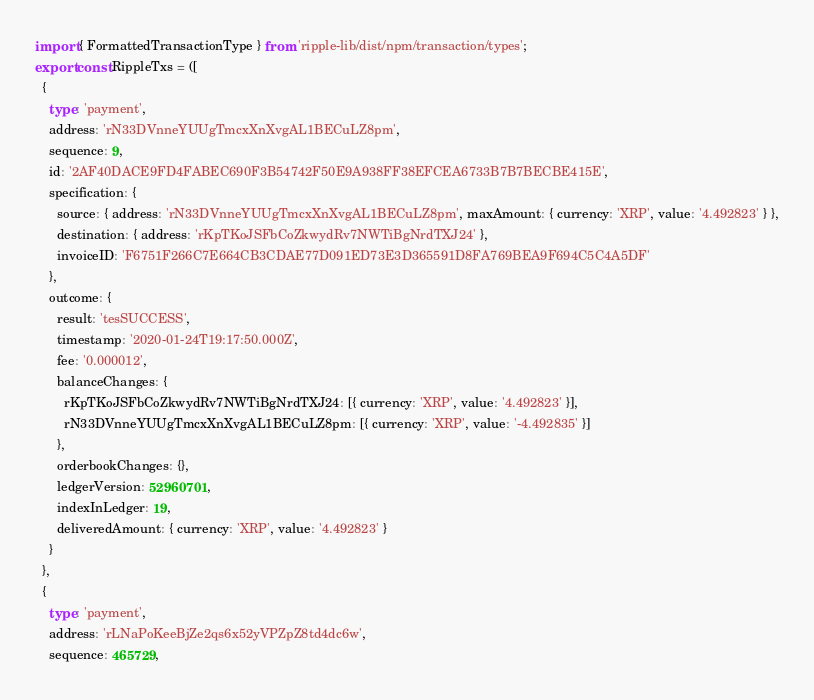Convert code to text. <code><loc_0><loc_0><loc_500><loc_500><_TypeScript_>import { FormattedTransactionType } from 'ripple-lib/dist/npm/transaction/types';
export const RippleTxs = ([
  {
    type: 'payment',
    address: 'rN33DVnneYUUgTmcxXnXvgAL1BECuLZ8pm',
    sequence: 9,
    id: '2AF40DACE9FD4FABEC690F3B54742F50E9A938FF38EFCEA6733B7B7BECBE415E',
    specification: {
      source: { address: 'rN33DVnneYUUgTmcxXnXvgAL1BECuLZ8pm', maxAmount: { currency: 'XRP', value: '4.492823' } },
      destination: { address: 'rKpTKoJSFbCoZkwydRv7NWTiBgNrdTXJ24' },
      invoiceID: 'F6751F266C7E664CB3CDAE77D091ED73E3D365591D8FA769BEA9F694C5C4A5DF'
    },
    outcome: {
      result: 'tesSUCCESS',
      timestamp: '2020-01-24T19:17:50.000Z',
      fee: '0.000012',
      balanceChanges: {
        rKpTKoJSFbCoZkwydRv7NWTiBgNrdTXJ24: [{ currency: 'XRP', value: '4.492823' }],
        rN33DVnneYUUgTmcxXnXvgAL1BECuLZ8pm: [{ currency: 'XRP', value: '-4.492835' }]
      },
      orderbookChanges: {},
      ledgerVersion: 52960701,
      indexInLedger: 19,
      deliveredAmount: { currency: 'XRP', value: '4.492823' }
    }
  },
  {
    type: 'payment',
    address: 'rLNaPoKeeBjZe2qs6x52yVPZpZ8td4dc6w',
    sequence: 465729,</code> 